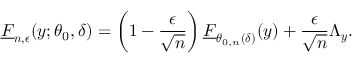<formula> <loc_0><loc_0><loc_500><loc_500>\underline { F } _ { n , \epsilon } ( y ; \theta _ { 0 } , \delta ) = \left ( 1 - \frac { \epsilon } { \sqrt { n } } \right ) \underline { F } _ { \theta _ { 0 , n } ( \delta ) } ( y ) + \frac { \epsilon } { \sqrt { n } } \Lambda _ { y } .</formula> 